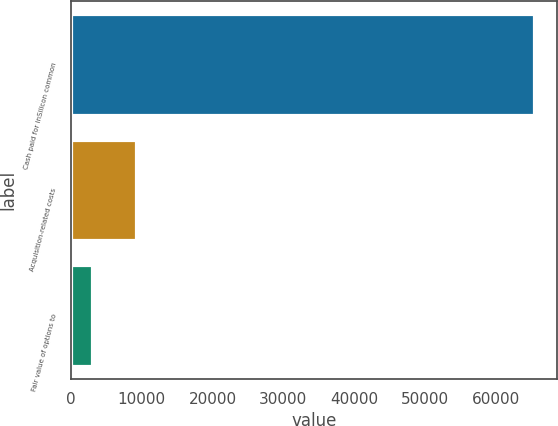Convert chart to OTSL. <chart><loc_0><loc_0><loc_500><loc_500><bar_chart><fcel>Cash paid for inSilicon common<fcel>Acquisition-related costs<fcel>Fair value of options to<nl><fcel>65386<fcel>9216.1<fcel>2975<nl></chart> 